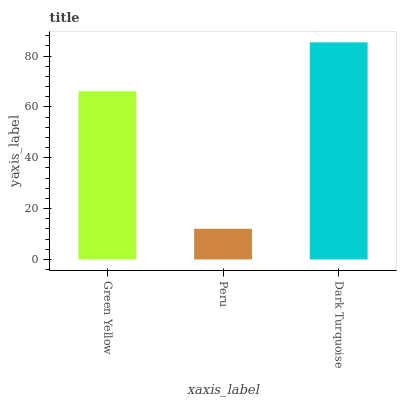Is Peru the minimum?
Answer yes or no. Yes. Is Dark Turquoise the maximum?
Answer yes or no. Yes. Is Dark Turquoise the minimum?
Answer yes or no. No. Is Peru the maximum?
Answer yes or no. No. Is Dark Turquoise greater than Peru?
Answer yes or no. Yes. Is Peru less than Dark Turquoise?
Answer yes or no. Yes. Is Peru greater than Dark Turquoise?
Answer yes or no. No. Is Dark Turquoise less than Peru?
Answer yes or no. No. Is Green Yellow the high median?
Answer yes or no. Yes. Is Green Yellow the low median?
Answer yes or no. Yes. Is Dark Turquoise the high median?
Answer yes or no. No. Is Peru the low median?
Answer yes or no. No. 